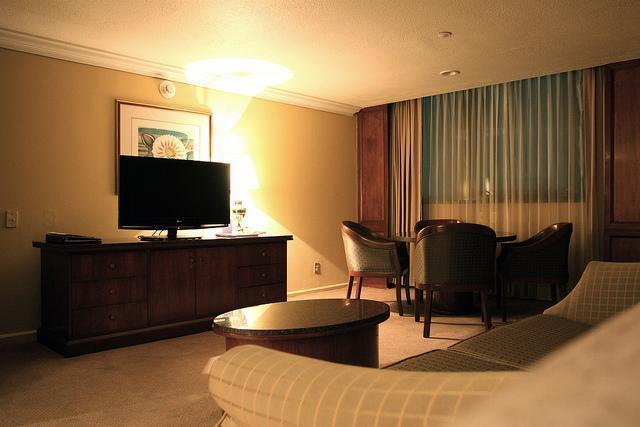How many chairs are in the picture?
Give a very brief answer. 3. How many people are wearing sunglasses?
Give a very brief answer. 0. 